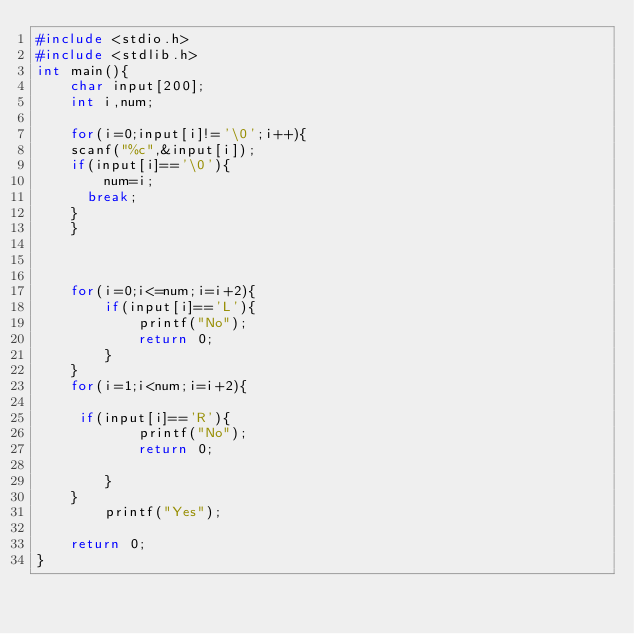<code> <loc_0><loc_0><loc_500><loc_500><_C_>#include <stdio.h>
#include <stdlib.h>
int main(){
    char input[200];
    int i,num;
    
    for(i=0;input[i]!='\0';i++){
    scanf("%c",&input[i]);
    if(input[i]=='\0'){
        num=i;
      break;
    }
    }    
    
    
    
    for(i=0;i<=num;i=i+2){
        if(input[i]=='L'){
            printf("No");
            return 0;
        }
    }
    for(i=1;i<num;i=i+2){
        
     if(input[i]=='R'){
            printf("No");
            return 0;
    
        }
    } 
        printf("Yes");
 
    return 0;
}
</code> 